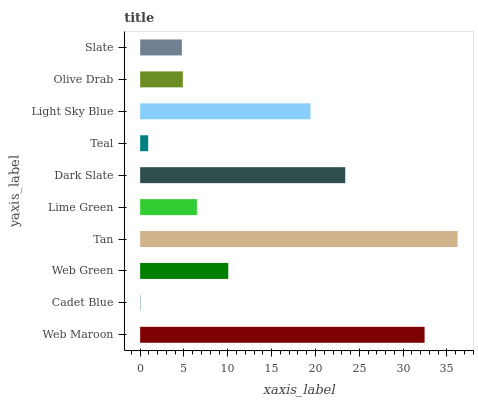Is Cadet Blue the minimum?
Answer yes or no. Yes. Is Tan the maximum?
Answer yes or no. Yes. Is Web Green the minimum?
Answer yes or no. No. Is Web Green the maximum?
Answer yes or no. No. Is Web Green greater than Cadet Blue?
Answer yes or no. Yes. Is Cadet Blue less than Web Green?
Answer yes or no. Yes. Is Cadet Blue greater than Web Green?
Answer yes or no. No. Is Web Green less than Cadet Blue?
Answer yes or no. No. Is Web Green the high median?
Answer yes or no. Yes. Is Lime Green the low median?
Answer yes or no. Yes. Is Light Sky Blue the high median?
Answer yes or no. No. Is Teal the low median?
Answer yes or no. No. 